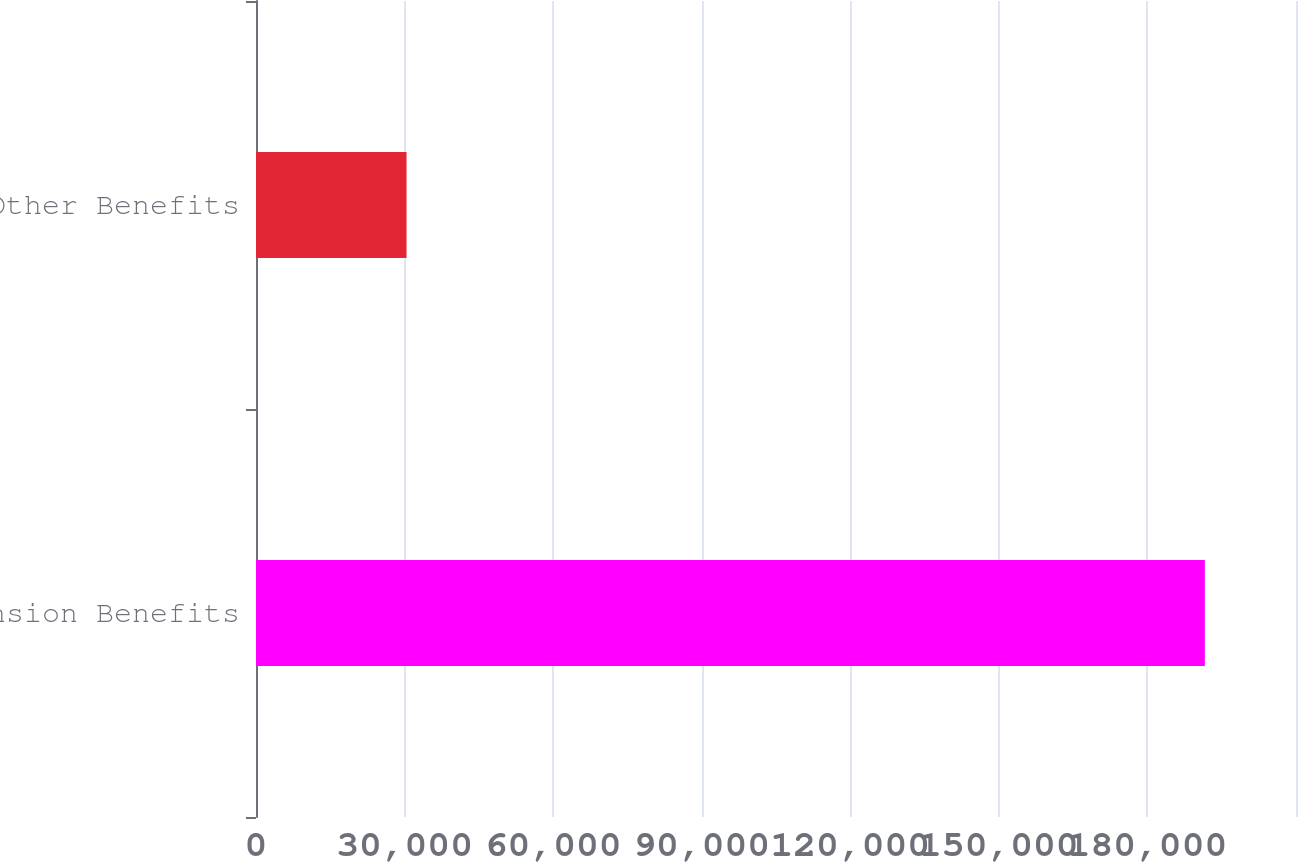<chart> <loc_0><loc_0><loc_500><loc_500><bar_chart><fcel>Pension Benefits<fcel>Other Benefits<nl><fcel>191593<fcel>30399<nl></chart> 